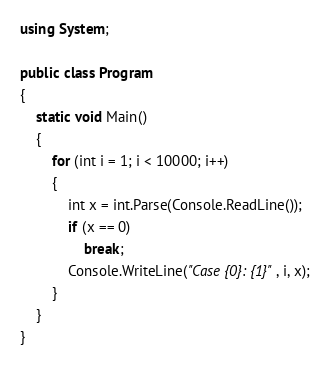Convert code to text. <code><loc_0><loc_0><loc_500><loc_500><_C#_>using System;

public class Program
{
    static void Main()
    {
        for (int i = 1; i < 10000; i++)
        {
            int x = int.Parse(Console.ReadLine());
            if (x == 0)
                break;
            Console.WriteLine("Case {0}: {1}", i, x);
        }
    }
}</code> 